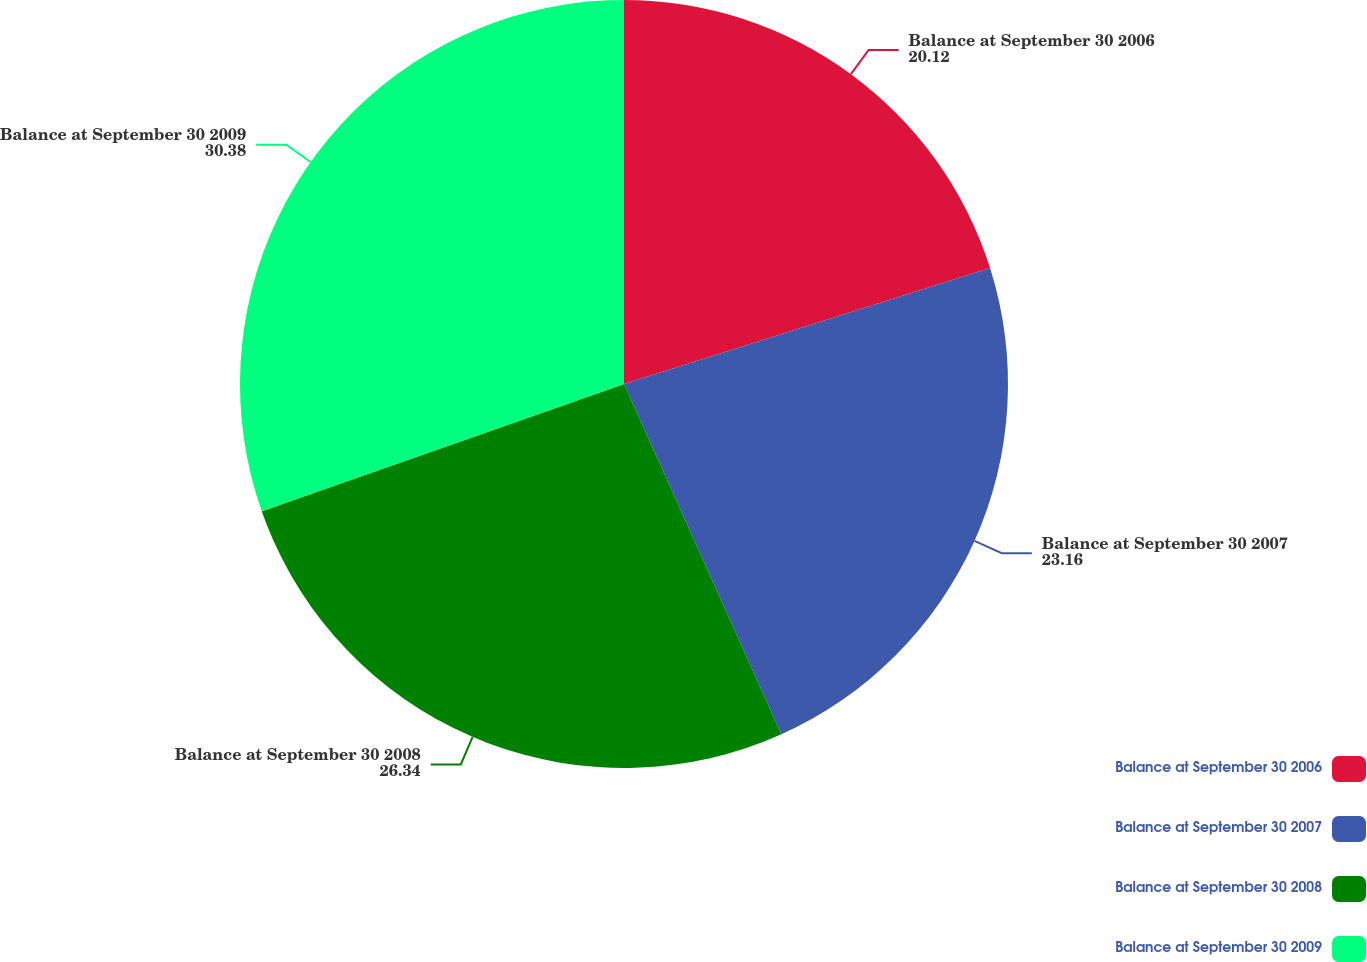<chart> <loc_0><loc_0><loc_500><loc_500><pie_chart><fcel>Balance at September 30 2006<fcel>Balance at September 30 2007<fcel>Balance at September 30 2008<fcel>Balance at September 30 2009<nl><fcel>20.12%<fcel>23.16%<fcel>26.34%<fcel>30.38%<nl></chart> 